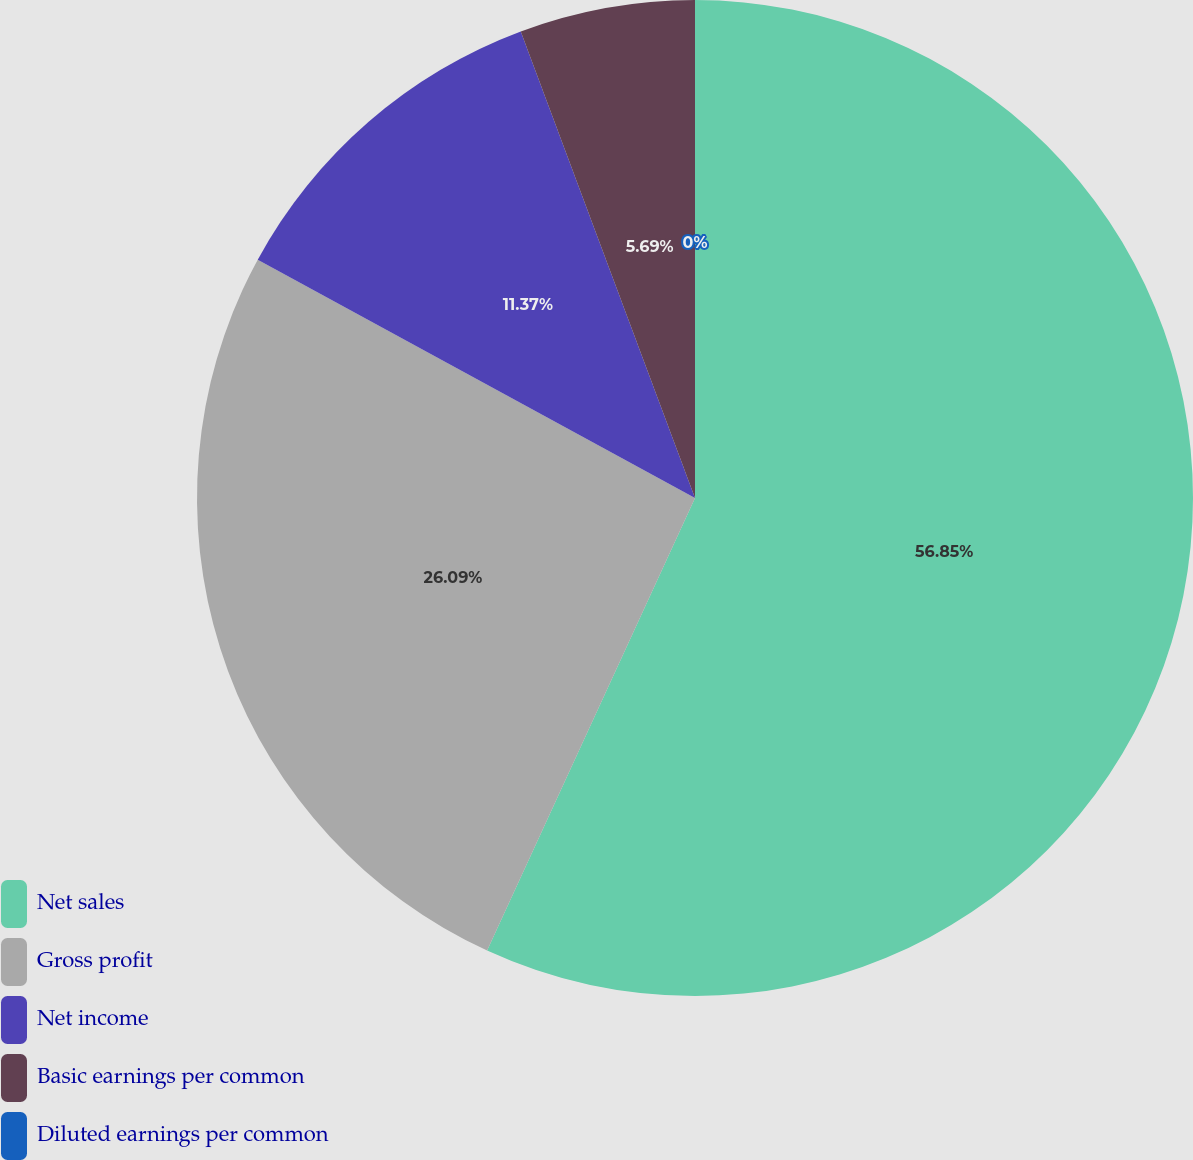<chart> <loc_0><loc_0><loc_500><loc_500><pie_chart><fcel>Net sales<fcel>Gross profit<fcel>Net income<fcel>Basic earnings per common<fcel>Diluted earnings per common<nl><fcel>56.86%<fcel>26.09%<fcel>11.37%<fcel>5.69%<fcel>0.0%<nl></chart> 